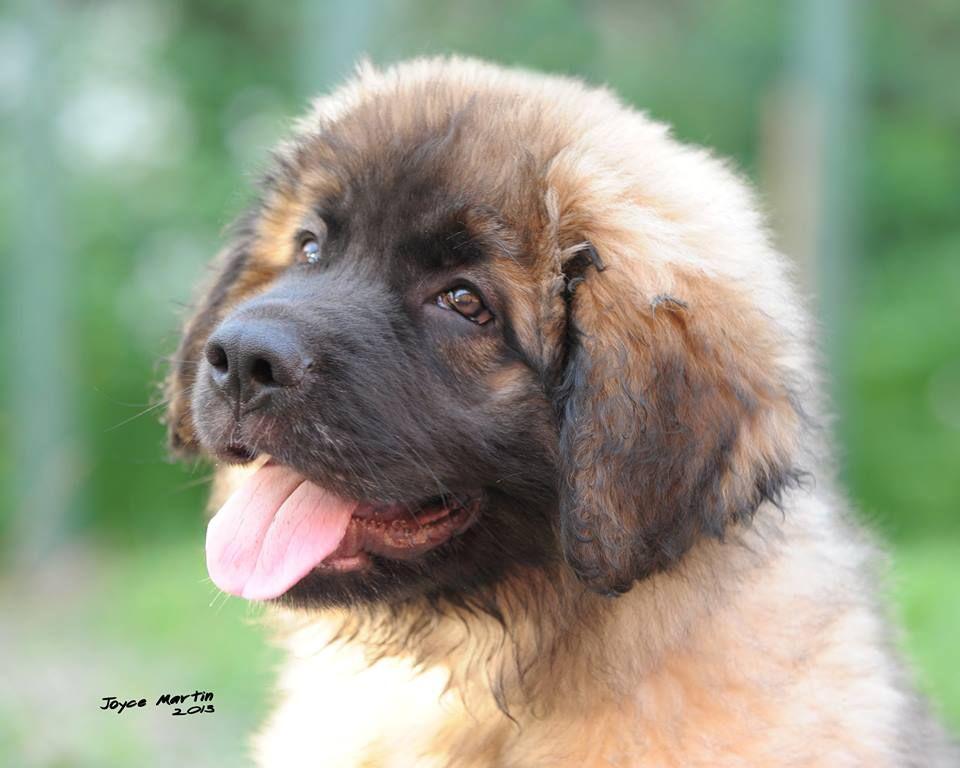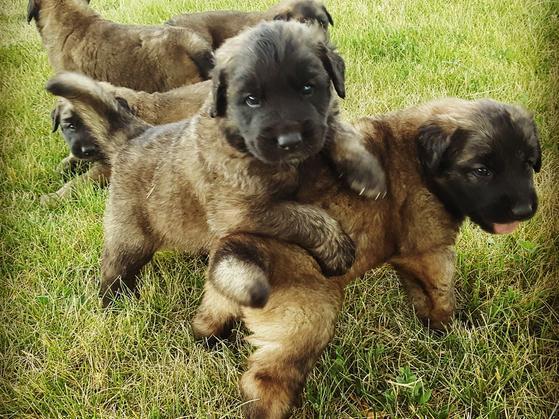The first image is the image on the left, the second image is the image on the right. Evaluate the accuracy of this statement regarding the images: "The right image contains at least four dogs.". Is it true? Answer yes or no. Yes. The first image is the image on the left, the second image is the image on the right. For the images shown, is this caption "One dog is on the back of another dog, and the image contains no more than five dogs." true? Answer yes or no. Yes. 